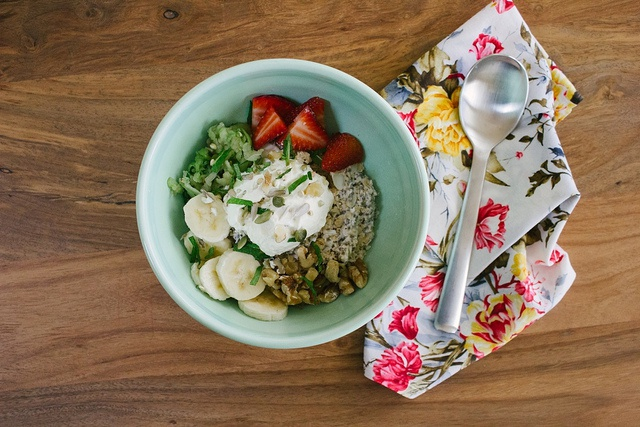Describe the objects in this image and their specific colors. I can see dining table in black, maroon, gray, and brown tones, bowl in black, lightgray, darkgray, and teal tones, spoon in black, darkgray, lightgray, and gray tones, and banana in black, lightgray, and tan tones in this image. 